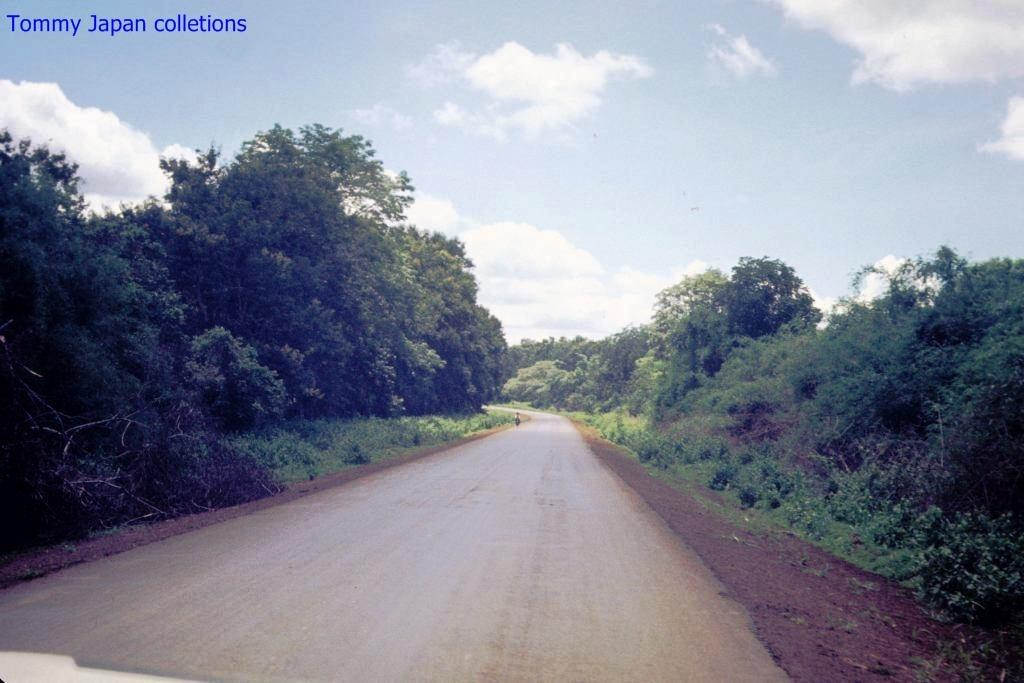What type of vegetation can be seen on both sides of the image? There are trees on both the right and left sides of the image. What is visible at the top of the image? The sky is visible at the top of the image. Can you describe any text present in the image? There is some text at the left top of the image. Can you see any friends riding a giraffe in the image? There are no friends or giraffes present in the image. Is there a carriage visible in the image? There is no carriage present in the image. 